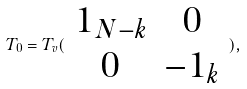<formula> <loc_0><loc_0><loc_500><loc_500>T _ { 0 } = T _ { v } ( \begin{array} { c c } 1 _ { N - k } & 0 \\ 0 & - 1 _ { k } \end{array} ) ,</formula> 